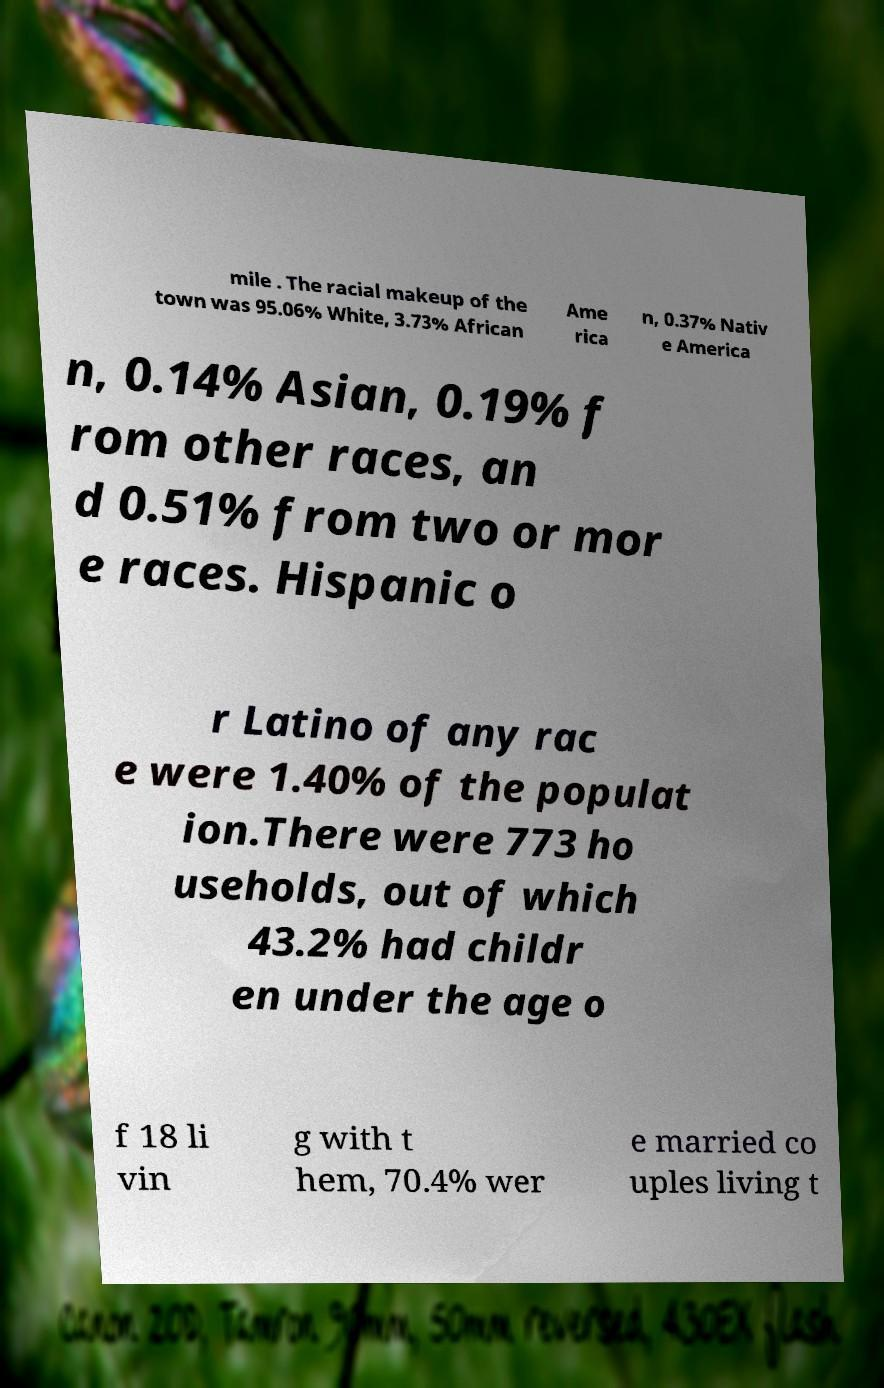Can you accurately transcribe the text from the provided image for me? mile . The racial makeup of the town was 95.06% White, 3.73% African Ame rica n, 0.37% Nativ e America n, 0.14% Asian, 0.19% f rom other races, an d 0.51% from two or mor e races. Hispanic o r Latino of any rac e were 1.40% of the populat ion.There were 773 ho useholds, out of which 43.2% had childr en under the age o f 18 li vin g with t hem, 70.4% wer e married co uples living t 